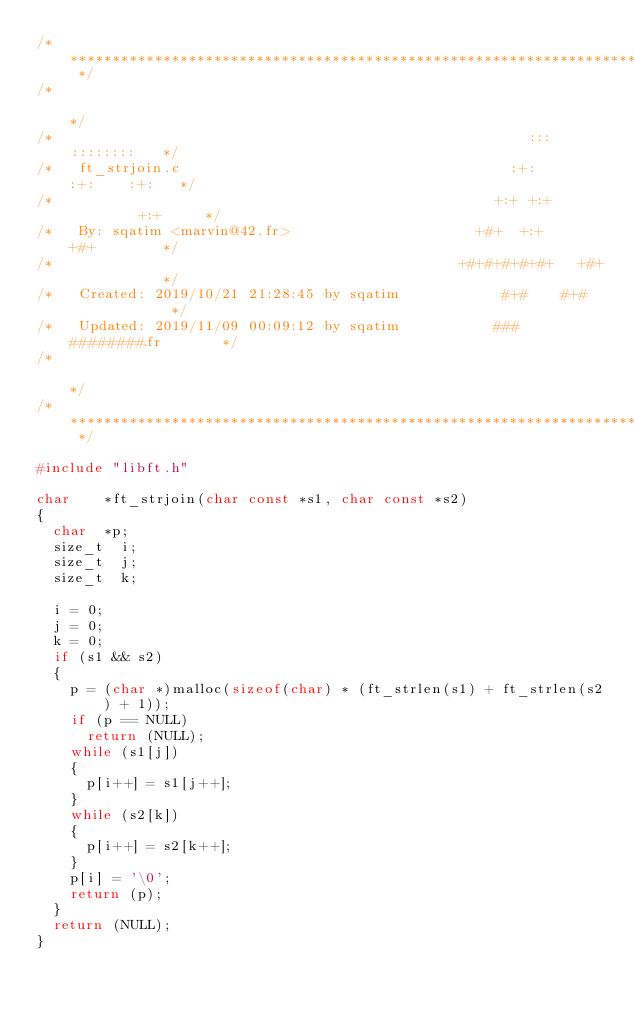Convert code to text. <code><loc_0><loc_0><loc_500><loc_500><_C_>/* ************************************************************************** */
/*                                                                            */
/*                                                        :::      ::::::::   */
/*   ft_strjoin.c                                       :+:      :+:    :+:   */
/*                                                    +:+ +:+         +:+     */
/*   By: sqatim <marvin@42.fr>                      +#+  +:+       +#+        */
/*                                                +#+#+#+#+#+   +#+           */
/*   Created: 2019/10/21 21:28:45 by sqatim            #+#    #+#             */
/*   Updated: 2019/11/09 00:09:12 by sqatim           ###   ########.fr       */
/*                                                                            */
/* ************************************************************************** */

#include "libft.h"

char		*ft_strjoin(char const *s1, char const *s2)
{
	char	*p;
	size_t	i;
	size_t	j;
	size_t	k;

	i = 0;
	j = 0;
	k = 0;
	if (s1 && s2)
	{
		p = (char *)malloc(sizeof(char) * (ft_strlen(s1) + ft_strlen(s2) + 1));
		if (p == NULL)
			return (NULL);
		while (s1[j])
		{
			p[i++] = s1[j++];
		}
		while (s2[k])
		{
			p[i++] = s2[k++];
		}
		p[i] = '\0';
		return (p);
	}
	return (NULL);
}
</code> 